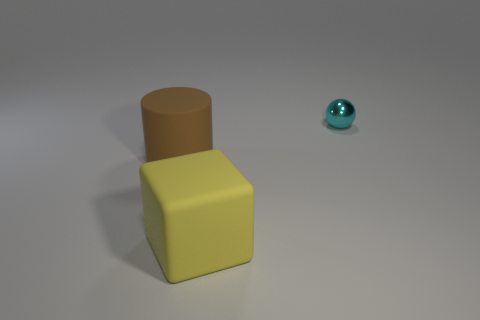Add 2 large red matte cylinders. How many objects exist? 5 Subtract all cubes. How many objects are left? 2 Subtract all brown cylinders. How many red blocks are left? 0 Subtract all yellow things. Subtract all large yellow metallic cubes. How many objects are left? 2 Add 3 yellow things. How many yellow things are left? 4 Add 1 gray spheres. How many gray spheres exist? 1 Subtract 0 cyan cylinders. How many objects are left? 3 